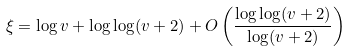<formula> <loc_0><loc_0><loc_500><loc_500>\xi = \log v + \log \log ( v + 2 ) + O \left ( \frac { \log \log ( v + 2 ) } { \log ( v + 2 ) } \right )</formula> 